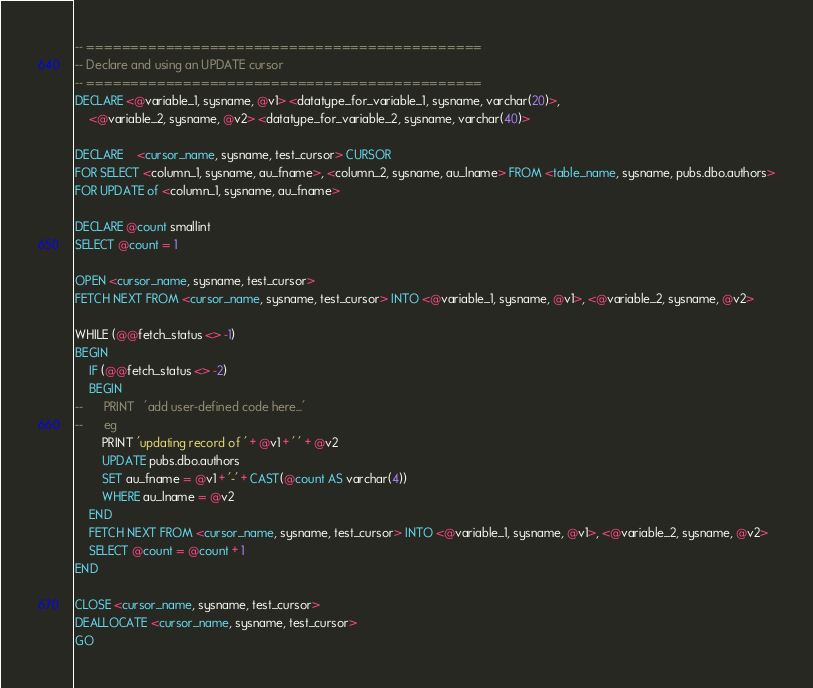<code> <loc_0><loc_0><loc_500><loc_500><_SQL_>-- =============================================
-- Declare and using an UPDATE cursor
-- =============================================
DECLARE <@variable_1, sysname, @v1> <datatype_for_variable_1, sysname, varchar(20)>, 
	<@variable_2, sysname, @v2> <datatype_for_variable_2, sysname, varchar(40)>

DECLARE	<cursor_name, sysname, test_cursor> CURSOR 
FOR SELECT <column_1, sysname, au_fname>, <column_2, sysname, au_lname> FROM <table_name, sysname, pubs.dbo.authors>
FOR UPDATE of <column_1, sysname, au_fname>

DECLARE @count smallint
SELECT @count = 1

OPEN <cursor_name, sysname, test_cursor>
FETCH NEXT FROM <cursor_name, sysname, test_cursor> INTO <@variable_1, sysname, @v1>, <@variable_2, sysname, @v2>

WHILE (@@fetch_status <> -1)
BEGIN
	IF (@@fetch_status <> -2)
	BEGIN
--		PRINT	'add user-defined code here...'
--		eg
		PRINT 'updating record of ' + @v1 + ' ' + @v2
		UPDATE pubs.dbo.authors
		SET au_fname = @v1 + '-' + CAST(@count AS varchar(4))
		WHERE au_lname = @v2
	END
	FETCH NEXT FROM <cursor_name, sysname, test_cursor> INTO <@variable_1, sysname, @v1>, <@variable_2, sysname, @v2>
	SELECT @count = @count + 1
END

CLOSE <cursor_name, sysname, test_cursor>
DEALLOCATE <cursor_name, sysname, test_cursor>
GO

</code> 